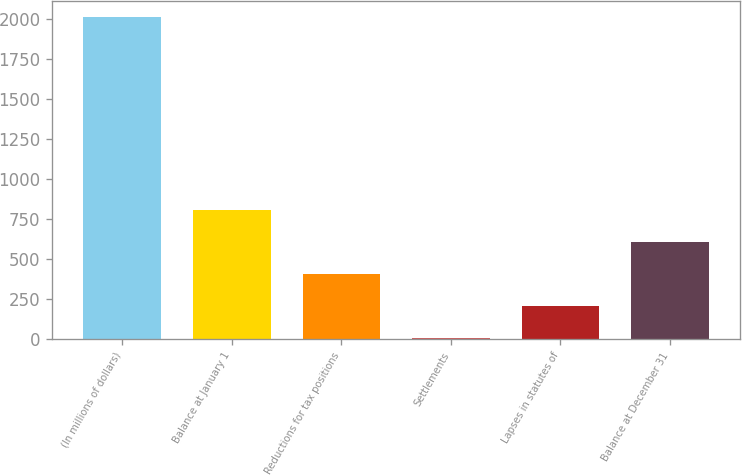Convert chart. <chart><loc_0><loc_0><loc_500><loc_500><bar_chart><fcel>(In millions of dollars)<fcel>Balance at January 1<fcel>Reductions for tax positions<fcel>Settlements<fcel>Lapses in statutes of<fcel>Balance at December 31<nl><fcel>2012<fcel>808.4<fcel>407.2<fcel>6<fcel>206.6<fcel>607.8<nl></chart> 